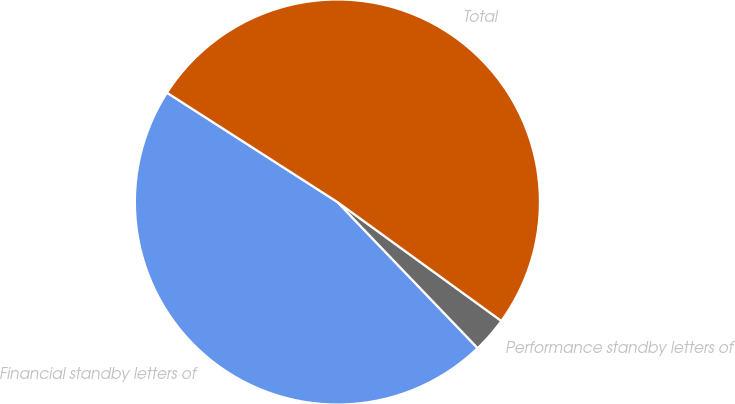Convert chart. <chart><loc_0><loc_0><loc_500><loc_500><pie_chart><fcel>Financial standby letters of<fcel>Performance standby letters of<fcel>Total<nl><fcel>46.25%<fcel>2.84%<fcel>50.91%<nl></chart> 